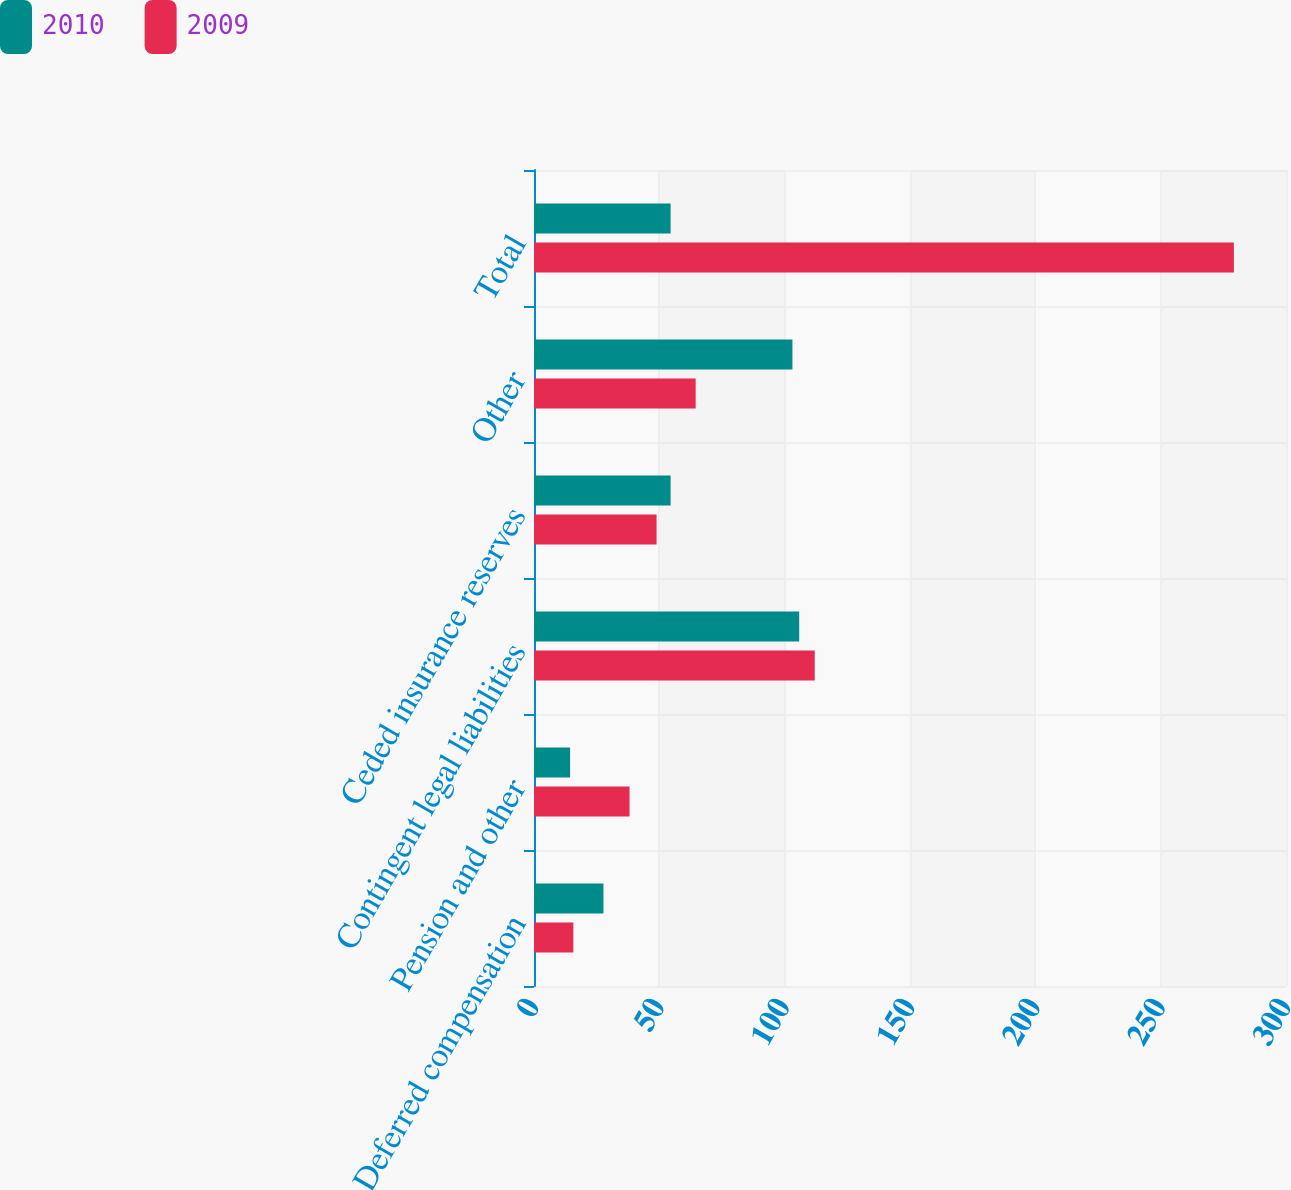Convert chart. <chart><loc_0><loc_0><loc_500><loc_500><stacked_bar_chart><ecel><fcel>Deferred compensation<fcel>Pension and other<fcel>Contingent legal liabilities<fcel>Ceded insurance reserves<fcel>Other<fcel>Total<nl><fcel>2010<fcel>27.7<fcel>14.4<fcel>105.8<fcel>54.5<fcel>103.1<fcel>54.5<nl><fcel>2009<fcel>15.7<fcel>38.1<fcel>112<fcel>48.9<fcel>64.5<fcel>279.2<nl></chart> 